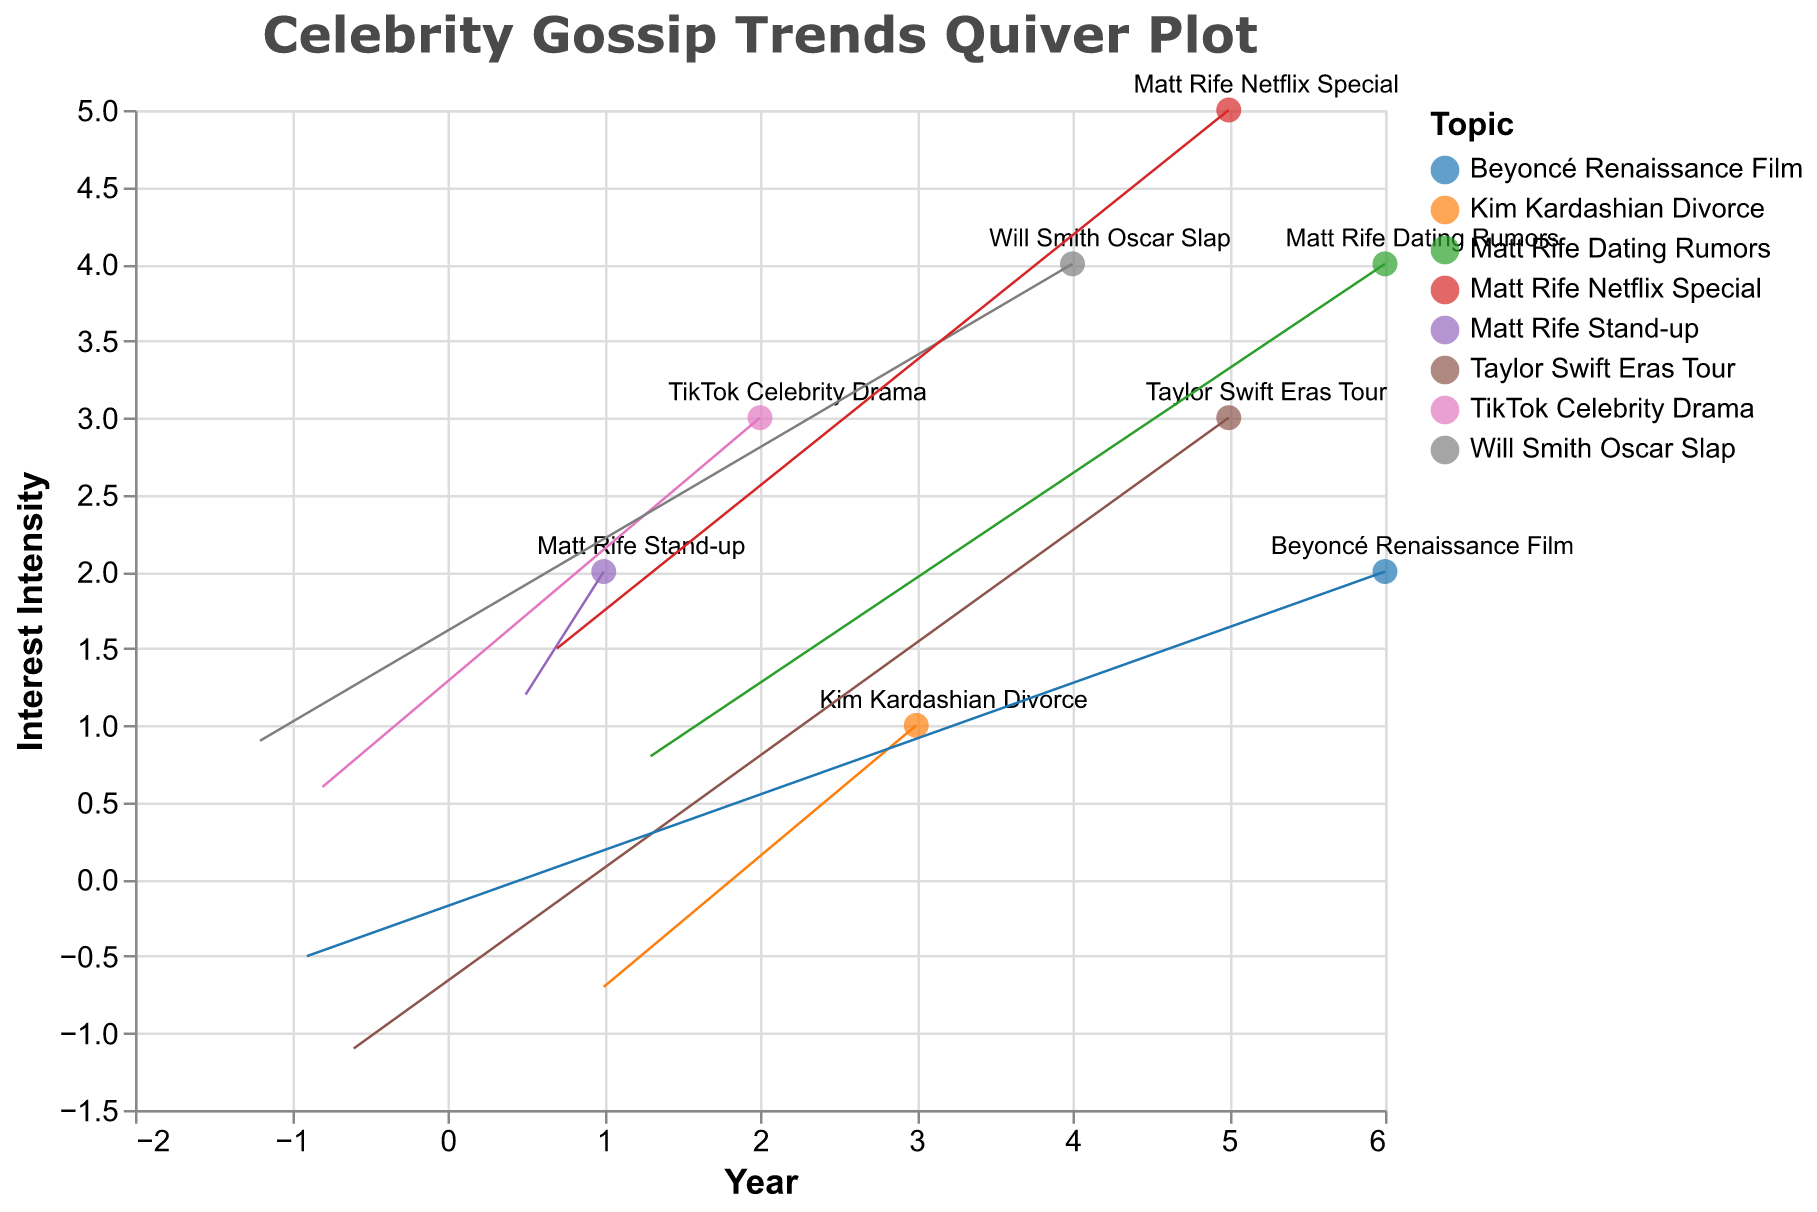What's the title of the plot? The title of the plot is usually displayed at the top of the figure. In this case, the title of the plot is "Celebrity Gossip Trends Quiver Plot".
Answer: Celebrity Gossip Trends Quiver Plot How many data points are shown in the figure? To determine the number of data points, count the number of entries in the data values provided. There are eight entries in the data values, hence, there are eight data points.
Answer: 8 Which year has the highest interest intensity for "Matt Rife Netflix Special"? Locate the data point with the topic "Matt Rife Netflix Special". It corresponds to the year 2023 and has a Y position of 5, indicating the highest interest intensity for that topic.
Answer: 2023 What is the interest intensity for "Will Smith Oscar Slap" compared to "Kim Kardashian Divorce"? The interest intensity is represented by the Y position. For "Will Smith Oscar Slap" in 2022, the Y position is 4. For "Kim Kardashian Divorce" in 2021, the Y position is 1, thus the interest intensity for Will Smith Oscar Slap is higher.
Answer: Higher What's the general direction of interest shift for "TikTok Celebrity Drama"? The direction is indicated by the vector (U, V). For "TikTok Celebrity Drama", the vector is (-0.8, 0.6), indicating a shift leftwards and upwards, meaning decreasing in X and increasing in Y.
Answer: Left and up Which topic shows a significant increase in interest intensity from 2023 to 2024? Compare the interest intensities (Y positions) for topics from 2023 to 2024. "Matt Rife Dating Rumors" in 2024 has a Y position of 4 which has increased from the Y position of "Matt Rife Netflix Special" of 5 in 2023. Another topic in 2024 is "Taylor Swift Eras Tour" from 2023 increased from 3 to 3 for "Beyoncé Renaissance Film" was compared the interest level. Therefore, Matt Rife Dating Rumors show significant increase.
Answer: Matt Rife Dating Rumors How does the trend of Matt Rife generally evolve over the years? Looking at the years 2019 ("Matt Rife Stand-up"), 2023 ("Matt Rife Netflix Special"), and 2024 ("Matt Rife Dating Rumors"), the X positions spread from 1 to 6 and the Y positions from 2 to 5 to 4, showing a growing and fluctuating trend in interest intensity.
Answer: Increasing and fluctuating Which topic in 2024 sees a decrease in interest intensity compared to its 2023 counterpart? Compare Y positions for both years. "Taylor Swift Eras Tour" from 2023 (Y = 3) does not appear in 2024 however "Beyoncé Renaissance Film" appears and the level shows could be compared here (2024 it is (Y = 2)).
Answer: Beyoncé Renaissance Film Between "Kim Kardashian Divorce" and "Matt Rife Netflix Special," which has a stronger intensity change? The vector lengths can indicate the change in intensity. For "Kim Kardashian Divorce," the vector is (1.0, -0.7). For "Matt Rife Netflix Special," the vector is (0.7, 1.5). Calculating the magnitude: sqrt(1.0^2 + (-0.7)^2) = 1.22 and sqrt(0.7^2 + 1.5^2) = 1.64. Matt Rife Netflix Special has a larger magnitude, thus more significant intensity change.
Answer: Matt Rife Netflix Special 